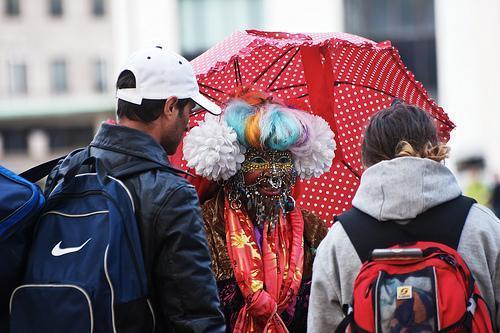How many people are shown?
Give a very brief answer. 3. How many people are facing away from the camera?
Give a very brief answer. 2. How many umbrellas are there?
Give a very brief answer. 1. 